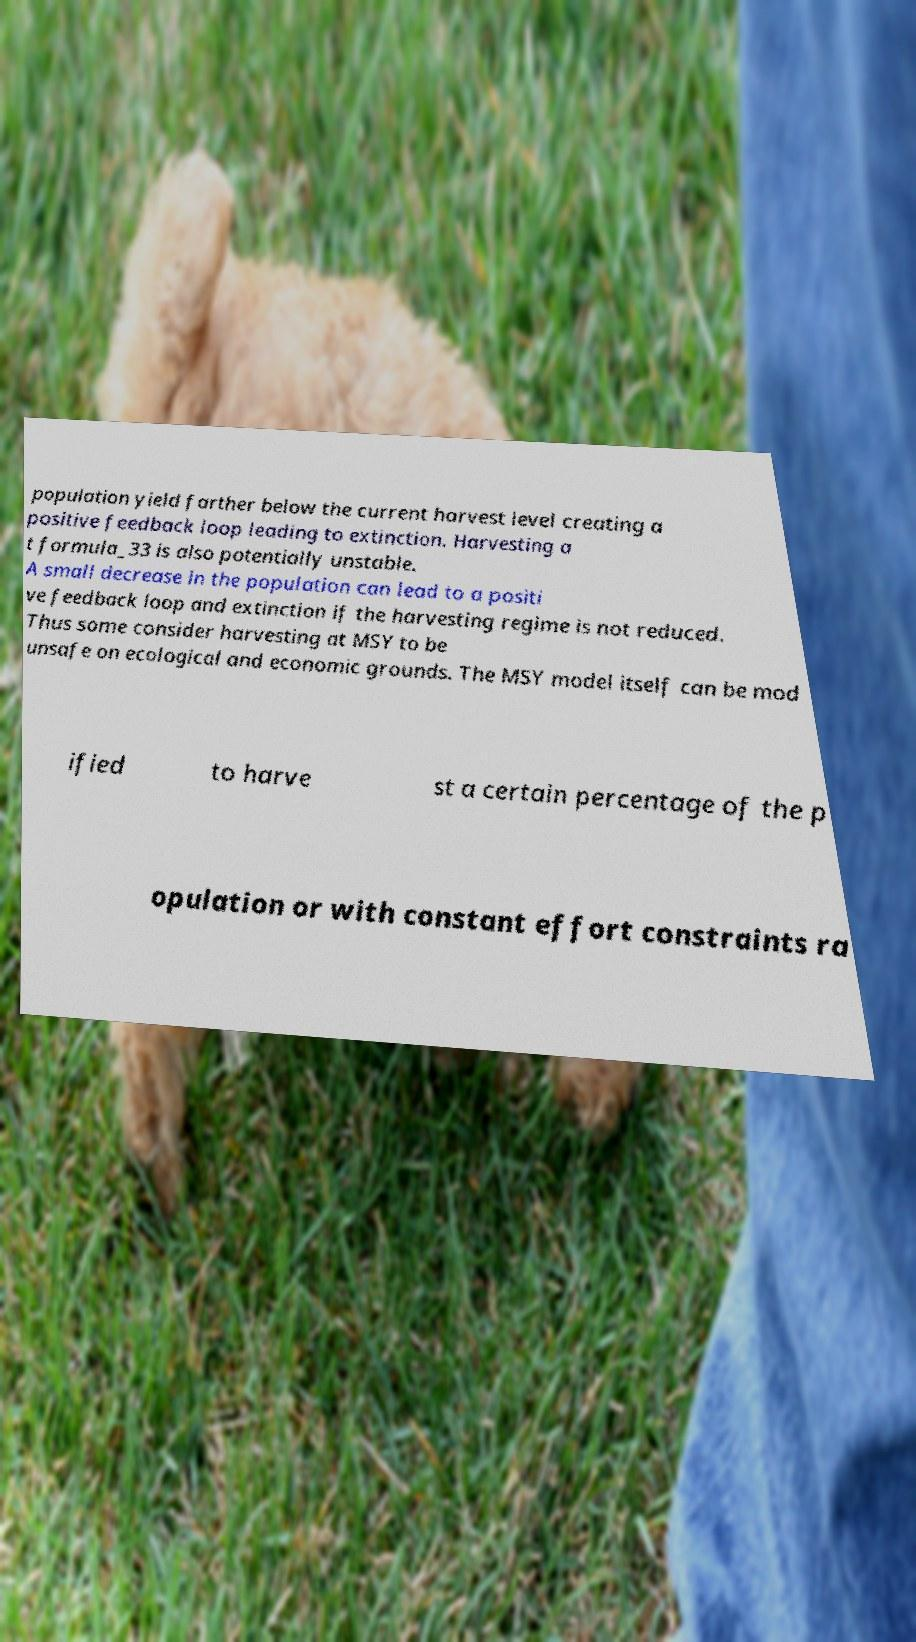Please identify and transcribe the text found in this image. population yield farther below the current harvest level creating a positive feedback loop leading to extinction. Harvesting a t formula_33 is also potentially unstable. A small decrease in the population can lead to a positi ve feedback loop and extinction if the harvesting regime is not reduced. Thus some consider harvesting at MSY to be unsafe on ecological and economic grounds. The MSY model itself can be mod ified to harve st a certain percentage of the p opulation or with constant effort constraints ra 